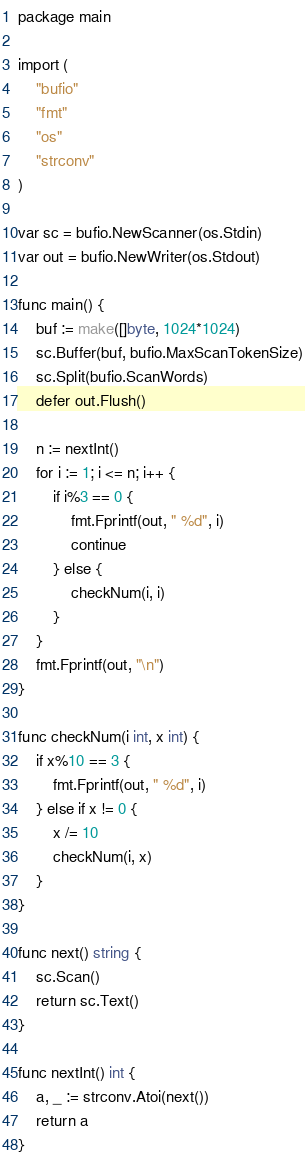Convert code to text. <code><loc_0><loc_0><loc_500><loc_500><_Go_>package main

import (
	"bufio"
	"fmt"
	"os"
	"strconv"
)

var sc = bufio.NewScanner(os.Stdin)
var out = bufio.NewWriter(os.Stdout)

func main() {
	buf := make([]byte, 1024*1024)
	sc.Buffer(buf, bufio.MaxScanTokenSize)
	sc.Split(bufio.ScanWords)
	defer out.Flush()

	n := nextInt()
	for i := 1; i <= n; i++ {
		if i%3 == 0 {
			fmt.Fprintf(out, " %d", i)
			continue
		} else {
			checkNum(i, i)
		}
	}
	fmt.Fprintf(out, "\n")
}

func checkNum(i int, x int) {
	if x%10 == 3 {
		fmt.Fprintf(out, " %d", i)
	} else if x != 0 {
		x /= 10
		checkNum(i, x)
	}
}

func next() string {
	sc.Scan()
	return sc.Text()
}

func nextInt() int {
	a, _ := strconv.Atoi(next())
	return a
}

</code> 